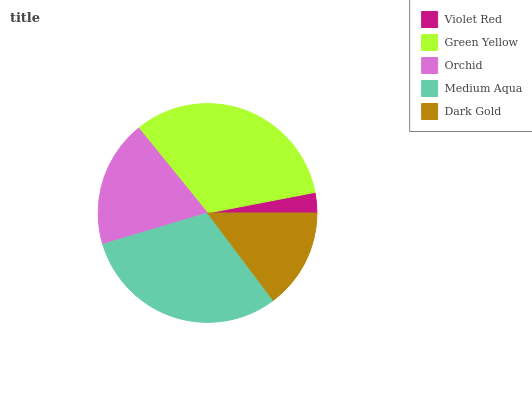Is Violet Red the minimum?
Answer yes or no. Yes. Is Green Yellow the maximum?
Answer yes or no. Yes. Is Orchid the minimum?
Answer yes or no. No. Is Orchid the maximum?
Answer yes or no. No. Is Green Yellow greater than Orchid?
Answer yes or no. Yes. Is Orchid less than Green Yellow?
Answer yes or no. Yes. Is Orchid greater than Green Yellow?
Answer yes or no. No. Is Green Yellow less than Orchid?
Answer yes or no. No. Is Orchid the high median?
Answer yes or no. Yes. Is Orchid the low median?
Answer yes or no. Yes. Is Violet Red the high median?
Answer yes or no. No. Is Dark Gold the low median?
Answer yes or no. No. 